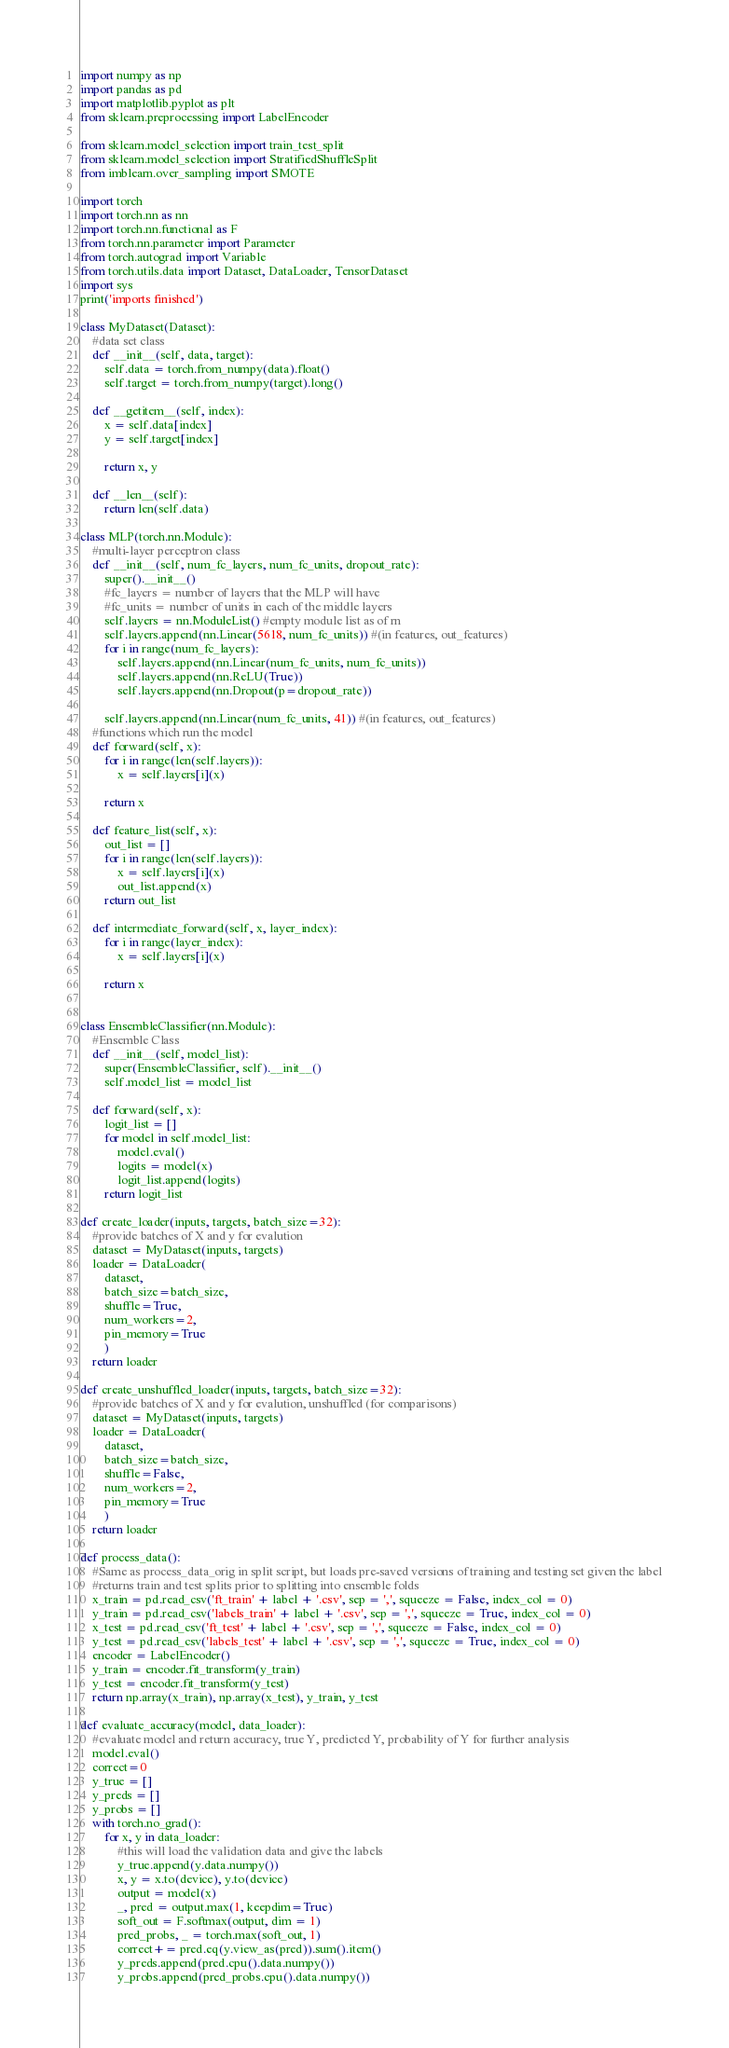Convert code to text. <code><loc_0><loc_0><loc_500><loc_500><_Python_>import numpy as np 
import pandas as pd 
import matplotlib.pyplot as plt 
from sklearn.preprocessing import LabelEncoder

from sklearn.model_selection import train_test_split
from sklearn.model_selection import StratifiedShuffleSplit
from imblearn.over_sampling import SMOTE

import torch 
import torch.nn as nn 
import torch.nn.functional as F 
from torch.nn.parameter import Parameter
from torch.autograd import Variable
from torch.utils.data import Dataset, DataLoader, TensorDataset
import sys
print('imports finished')

class MyDataset(Dataset):
	#data set class
	def __init__(self, data, target): 
		self.data = torch.from_numpy(data).float()
		self.target = torch.from_numpy(target).long()

	def __getitem__(self, index):
		x = self.data[index]
		y = self.target[index]

		return x, y

	def __len__(self): 
		return len(self.data)

class MLP(torch.nn.Module):
	#multi-layer perceptron class
	def __init__(self, num_fc_layers, num_fc_units, dropout_rate):
		super().__init__()
		#fc_layers = number of layers that the MLP will have
		#fc_units = number of units in each of the middle layers
		self.layers = nn.ModuleList() #empty module list as of rn
		self.layers.append(nn.Linear(5618, num_fc_units)) #(in features, out_features)
		for i in range(num_fc_layers):
			self.layers.append(nn.Linear(num_fc_units, num_fc_units))
			self.layers.append(nn.ReLU(True))
			self.layers.append(nn.Dropout(p=dropout_rate))

		self.layers.append(nn.Linear(num_fc_units, 41)) #(in features, out_features)
	#functions which run the model
	def forward(self, x): 
		for i in range(len(self.layers)): 
			x = self.layers[i](x)

		return x

	def feature_list(self, x): 
		out_list = []
		for i in range(len(self.layers)): 
			x = self.layers[i](x)
			out_list.append(x)
		return out_list

	def intermediate_forward(self, x, layer_index):
		for i in range(layer_index): 
			x = self.layers[i](x)

		return x


class EnsembleClassifier(nn.Module):
	#Ensemble Class
	def __init__(self, model_list): 
		super(EnsembleClassifier, self).__init__()
		self.model_list = model_list

	def forward(self, x): 
		logit_list = [] 
		for model in self.model_list: 
			model.eval()
			logits = model(x)
			logit_list.append(logits)
		return logit_list 

def create_loader(inputs, targets, batch_size=32): 
	#provide batches of X and y for evalution
	dataset = MyDataset(inputs, targets)
	loader = DataLoader(
		dataset,
		batch_size=batch_size,
		shuffle=True,
		num_workers=2,
		pin_memory=True
		)
	return loader

def create_unshuffled_loader(inputs, targets, batch_size=32): 
	#provide batches of X and y for evalution, unshuffled (for comparisons)
	dataset = MyDataset(inputs, targets)
	loader = DataLoader(
		dataset,
		batch_size=batch_size,
		shuffle=False,
		num_workers=2,
		pin_memory=True
		)
	return loader 

def process_data(): 
	#Same as process_data_orig in split script, but loads pre-saved versions of training and testing set given the label
	#returns train and test splits prior to splitting into ensemble folds
	x_train = pd.read_csv('ft_train' + label + '.csv', sep = ',', squeeze = False, index_col = 0)
	y_train = pd.read_csv('labels_train' + label + '.csv', sep = ',', squeeze = True, index_col = 0)
	x_test = pd.read_csv('ft_test' + label + '.csv', sep = ',', squeeze = False, index_col = 0)
	y_test = pd.read_csv('labels_test' + label + '.csv', sep = ',', squeeze = True, index_col = 0)
	encoder = LabelEncoder()
	y_train = encoder.fit_transform(y_train)
	y_test = encoder.fit_transform(y_test)
	return np.array(x_train), np.array(x_test), y_train, y_test

def evaluate_accuracy(model, data_loader): 
	#evaluate model and return accuracy, true Y, predicted Y, probability of Y for further analysis
	model.eval()
	correct=0
	y_true = []
	y_preds = []
	y_probs = []
	with torch.no_grad(): 
		for x, y in data_loader:
			#this will load the validation data and give the labels 
			y_true.append(y.data.numpy())
			x, y = x.to(device), y.to(device)
			output = model(x)
			_, pred = output.max(1, keepdim=True)
			soft_out = F.softmax(output, dim = 1)
			pred_probs, _ = torch.max(soft_out, 1)
			correct+= pred.eq(y.view_as(pred)).sum().item()			
			y_preds.append(pred.cpu().data.numpy())	
			y_probs.append(pred_probs.cpu().data.numpy())</code> 